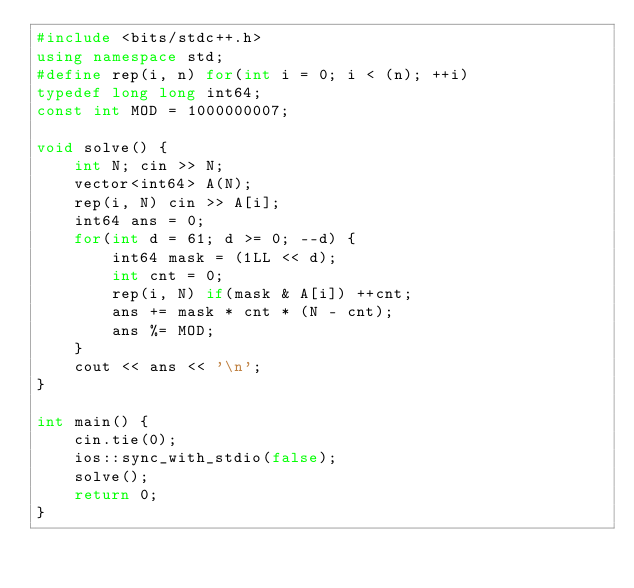Convert code to text. <code><loc_0><loc_0><loc_500><loc_500><_C++_>#include <bits/stdc++.h>
using namespace std;
#define rep(i, n) for(int i = 0; i < (n); ++i)
typedef long long int64;
const int MOD = 1000000007;

void solve() {
    int N; cin >> N;
    vector<int64> A(N);
    rep(i, N) cin >> A[i];
    int64 ans = 0;
    for(int d = 61; d >= 0; --d) {
        int64 mask = (1LL << d);
        int cnt = 0;
        rep(i, N) if(mask & A[i]) ++cnt;
        ans += mask * cnt * (N - cnt);
        ans %= MOD;
    }
    cout << ans << '\n';
}

int main() {
    cin.tie(0);
    ios::sync_with_stdio(false);
    solve();
    return 0;
}
</code> 